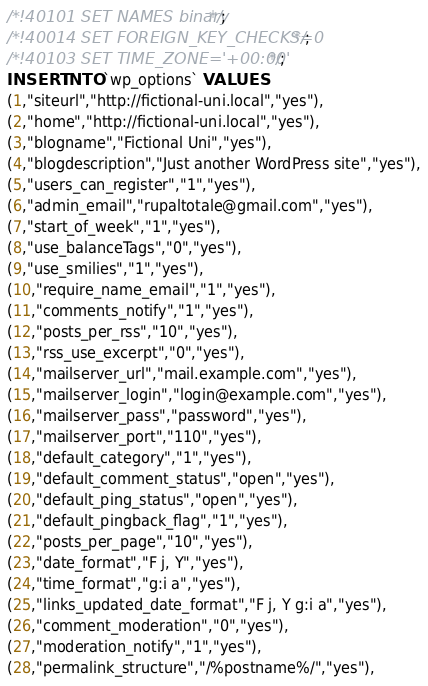Convert code to text. <code><loc_0><loc_0><loc_500><loc_500><_SQL_>/*!40101 SET NAMES binary*/;
/*!40014 SET FOREIGN_KEY_CHECKS=0*/;
/*!40103 SET TIME_ZONE='+00:00' */;
INSERT INTO `wp_options` VALUES
(1,"siteurl","http://fictional-uni.local","yes"),
(2,"home","http://fictional-uni.local","yes"),
(3,"blogname","Fictional Uni","yes"),
(4,"blogdescription","Just another WordPress site","yes"),
(5,"users_can_register","1","yes"),
(6,"admin_email","rupaltotale@gmail.com","yes"),
(7,"start_of_week","1","yes"),
(8,"use_balanceTags","0","yes"),
(9,"use_smilies","1","yes"),
(10,"require_name_email","1","yes"),
(11,"comments_notify","1","yes"),
(12,"posts_per_rss","10","yes"),
(13,"rss_use_excerpt","0","yes"),
(14,"mailserver_url","mail.example.com","yes"),
(15,"mailserver_login","login@example.com","yes"),
(16,"mailserver_pass","password","yes"),
(17,"mailserver_port","110","yes"),
(18,"default_category","1","yes"),
(19,"default_comment_status","open","yes"),
(20,"default_ping_status","open","yes"),
(21,"default_pingback_flag","1","yes"),
(22,"posts_per_page","10","yes"),
(23,"date_format","F j, Y","yes"),
(24,"time_format","g:i a","yes"),
(25,"links_updated_date_format","F j, Y g:i a","yes"),
(26,"comment_moderation","0","yes"),
(27,"moderation_notify","1","yes"),
(28,"permalink_structure","/%postname%/","yes"),</code> 